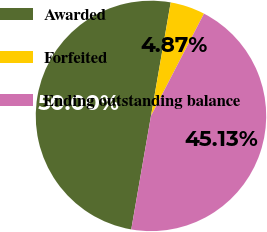Convert chart. <chart><loc_0><loc_0><loc_500><loc_500><pie_chart><fcel>Awarded<fcel>Forfeited<fcel>Ending outstanding balance<nl><fcel>50.0%<fcel>4.87%<fcel>45.13%<nl></chart> 